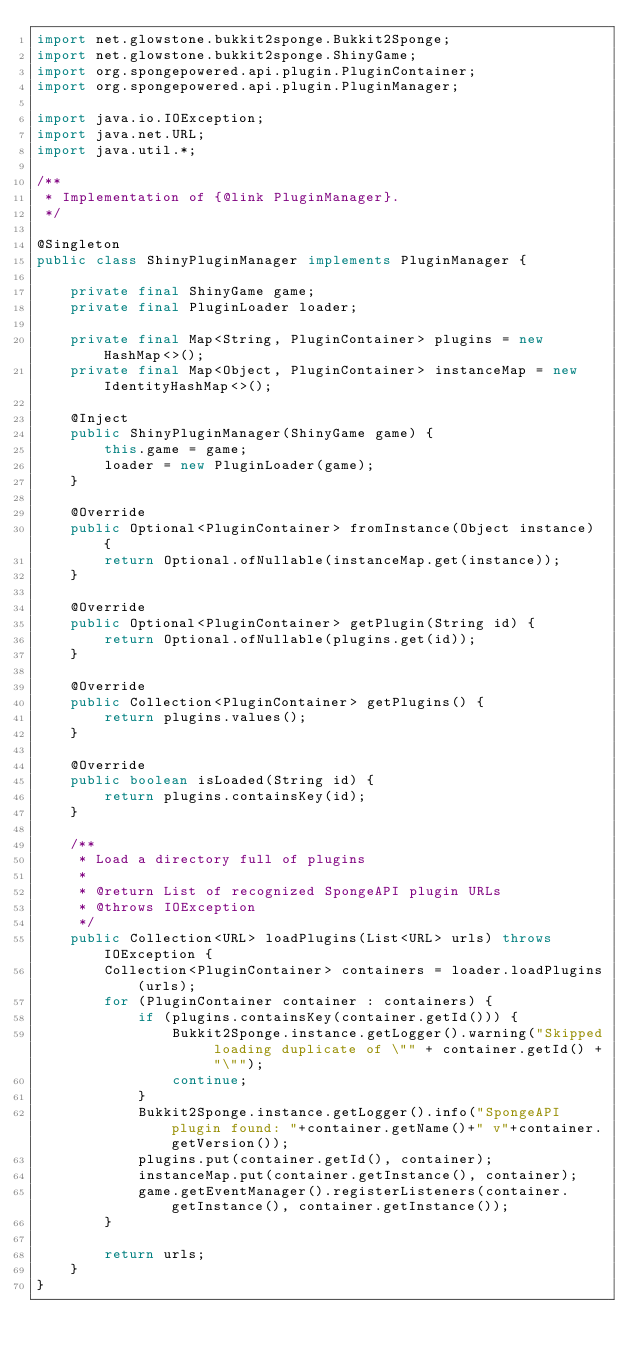<code> <loc_0><loc_0><loc_500><loc_500><_Java_>import net.glowstone.bukkit2sponge.Bukkit2Sponge;
import net.glowstone.bukkit2sponge.ShinyGame;
import org.spongepowered.api.plugin.PluginContainer;
import org.spongepowered.api.plugin.PluginManager;

import java.io.IOException;
import java.net.URL;
import java.util.*;

/**
 * Implementation of {@link PluginManager}.
 */

@Singleton
public class ShinyPluginManager implements PluginManager {

    private final ShinyGame game;
    private final PluginLoader loader;

    private final Map<String, PluginContainer> plugins = new HashMap<>();
    private final Map<Object, PluginContainer> instanceMap = new IdentityHashMap<>();

    @Inject
    public ShinyPluginManager(ShinyGame game) {
        this.game = game;
        loader = new PluginLoader(game);
    }

    @Override
    public Optional<PluginContainer> fromInstance(Object instance) {
        return Optional.ofNullable(instanceMap.get(instance));
    }

    @Override
    public Optional<PluginContainer> getPlugin(String id) {
        return Optional.ofNullable(plugins.get(id));
    }

    @Override
    public Collection<PluginContainer> getPlugins() {
        return plugins.values();
    }

    @Override
    public boolean isLoaded(String id) {
        return plugins.containsKey(id);
    }

    /**
     * Load a directory full of plugins
     *
     * @return List of recognized SpongeAPI plugin URLs
     * @throws IOException
     */
    public Collection<URL> loadPlugins(List<URL> urls) throws IOException {
        Collection<PluginContainer> containers = loader.loadPlugins(urls);
        for (PluginContainer container : containers) {
            if (plugins.containsKey(container.getId())) {
                Bukkit2Sponge.instance.getLogger().warning("Skipped loading duplicate of \"" + container.getId() + "\"");
                continue;
            }
            Bukkit2Sponge.instance.getLogger().info("SpongeAPI plugin found: "+container.getName()+" v"+container.getVersion());
            plugins.put(container.getId(), container);
            instanceMap.put(container.getInstance(), container);
            game.getEventManager().registerListeners(container.getInstance(), container.getInstance());
        }

        return urls;
    }
}
</code> 